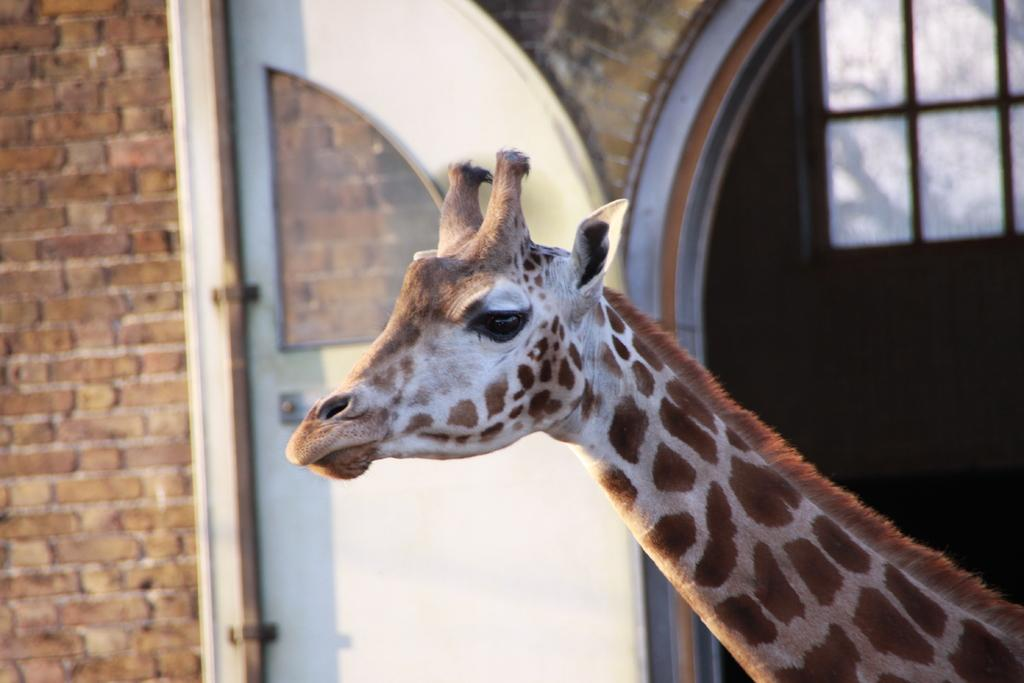What animal is present in the image? There is a giraffe in the image. What type of structures can be seen in the background of the image? There are doors and walls in the background of the image. What type of needle is being used by the giraffe in the image? There is no needle present in the image, as it features a giraffe and background structures. 